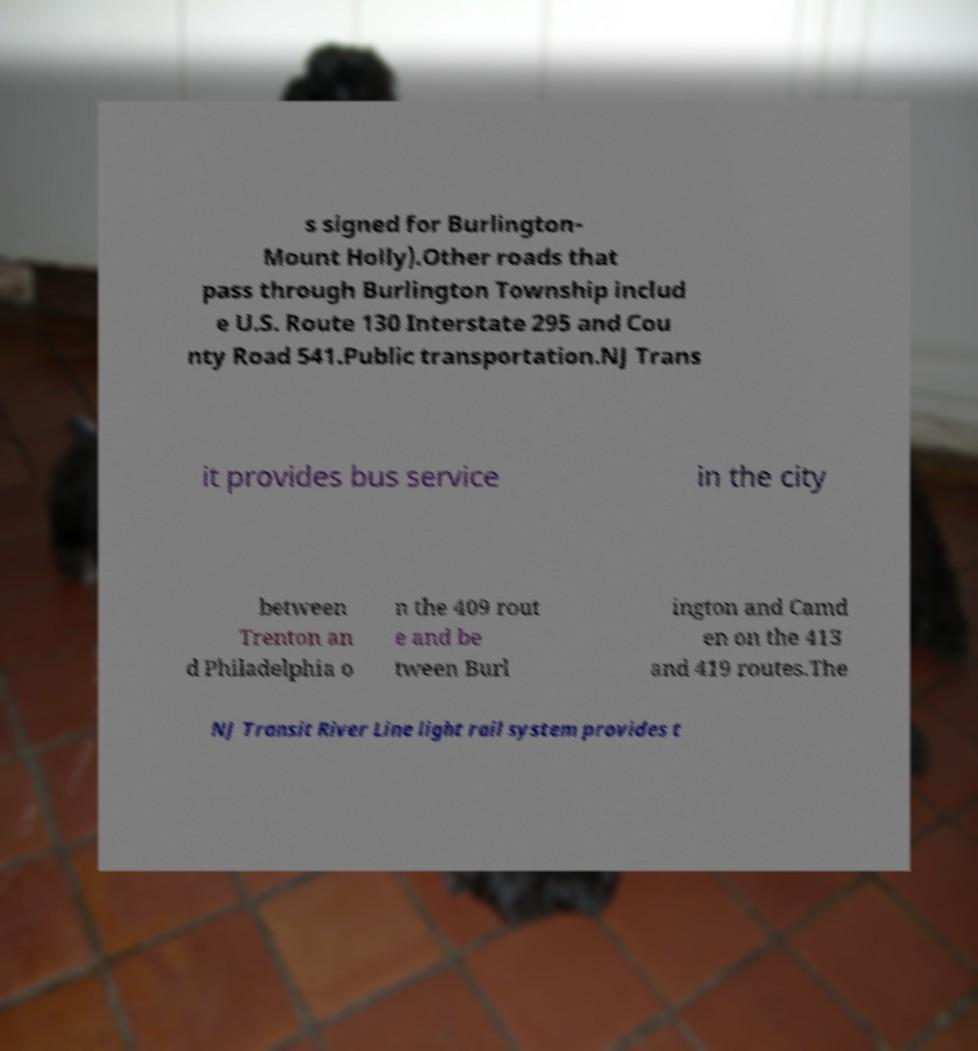For documentation purposes, I need the text within this image transcribed. Could you provide that? s signed for Burlington- Mount Holly).Other roads that pass through Burlington Township includ e U.S. Route 130 Interstate 295 and Cou nty Road 541.Public transportation.NJ Trans it provides bus service in the city between Trenton an d Philadelphia o n the 409 rout e and be tween Burl ington and Camd en on the 413 and 419 routes.The NJ Transit River Line light rail system provides t 